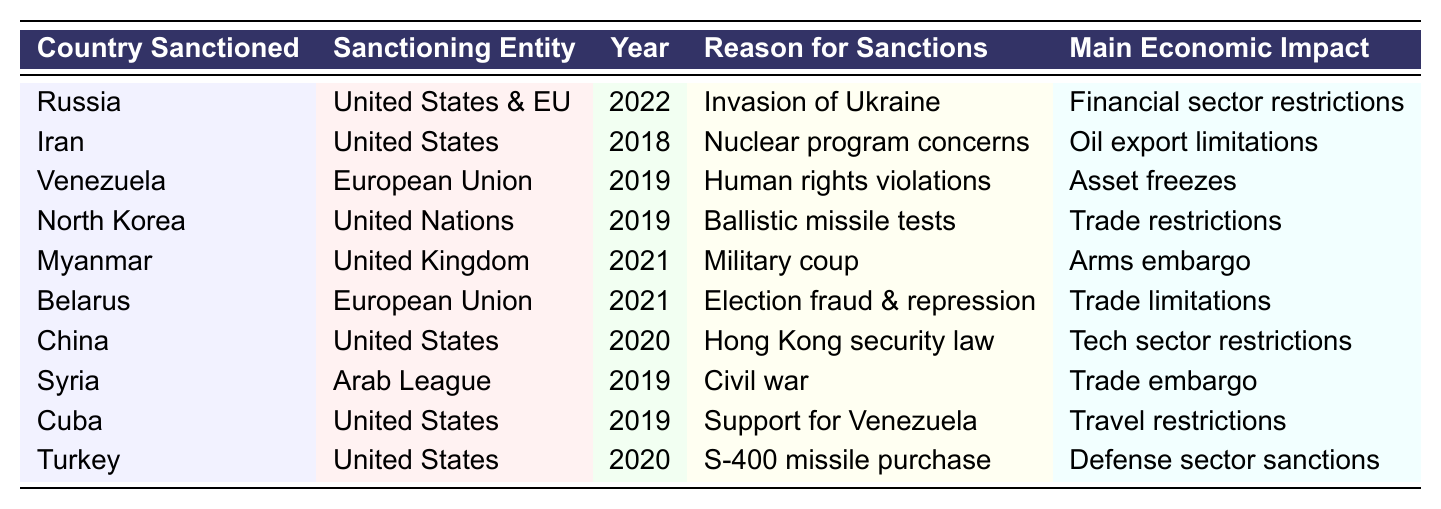What countries were sanctioned by the United States? The table lists countries sanctioned by the United States, specifically Russia, Iran, China, Cuba, and Turkey.
Answer: Russia, Iran, China, Cuba, Turkey In which year were sanctions imposed on North Korea? According to the table, sanctions on North Korea were imposed in the year 2019.
Answer: 2019 How many countries were sanctioned in 2021? The countries sanctioned in 2021 are Myanmar and Belarus, totaling 2 countries.
Answer: 2 What was the economic impact of sanctions on Venezuela? The table indicates that the main economic impact of sanctions on Venezuela was asset freezes.
Answer: Asset freezes Did the European Union impose sanctions on Myanmar? The table shows that Myanmar was sanctioned by the United Kingdom, not the European Union.
Answer: No Which country faced sanctions for the invasion of Ukraine? The table clearly states that Russia faced sanctions for the invasion of Ukraine in 2022.
Answer: Russia What is the reason for the sanctions imposed on Iran? The table lists "Nuclear program concerns" as the reason for the sanctions imposed on Iran.
Answer: Nuclear program concerns Which sanctioning entity imposed restrictions on China's tech sector? The sanctions on China's tech sector were imposed by the United States, as indicated in the table.
Answer: United States Was there a trade embargo placed on Syria? Yes, the table states that a trade embargo was enforced against Syria during the civil war.
Answer: Yes How many countries were sanctioned due to concerns related to human rights? The table lists Venezuela as sanctioned for human rights violations, amounting to 1 country.
Answer: 1 What type of restrictions did Turkey face due to its missile purchase? The table mentions that Turkey faced defense sector sanctions due to the S-400 missile purchase.
Answer: Defense sector sanctions Which country had sanctions related to both trade limitations and election fraud? According to the table, Belarus had sanctions related to trade limitations due to election fraud and repression.
Answer: Belarus Name the countries that were sanctioned in the year 2019. The countries sanctioned in 2019 were Venezuela, North Korea, and Cuba, totaling 3 countries.
Answer: Venezuela, North Korea, Cuba Identify the sanctions imposed on Myanmar in 2021. The table shows that the sanctions imposed on Myanmar in 2021 were classified as an arms embargo.
Answer: Arms embargo 